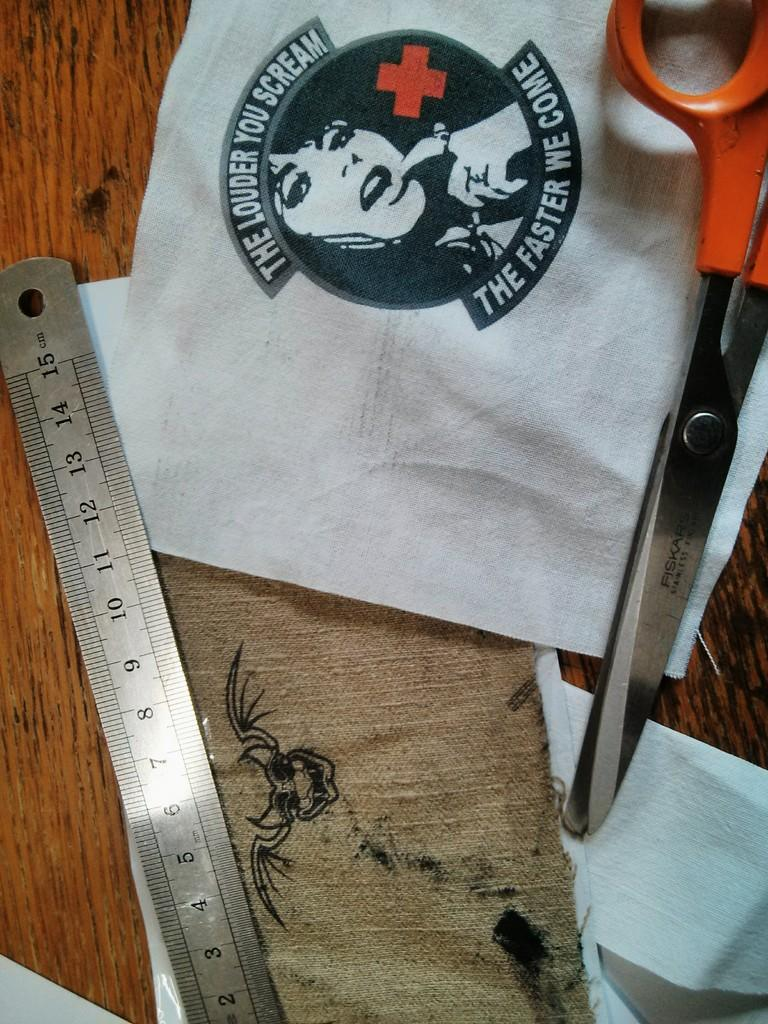Provide a one-sentence caption for the provided image. the steel rule,fiskars scissors and white cloth printed the louder you scream the faster we come , are placed in the table. 